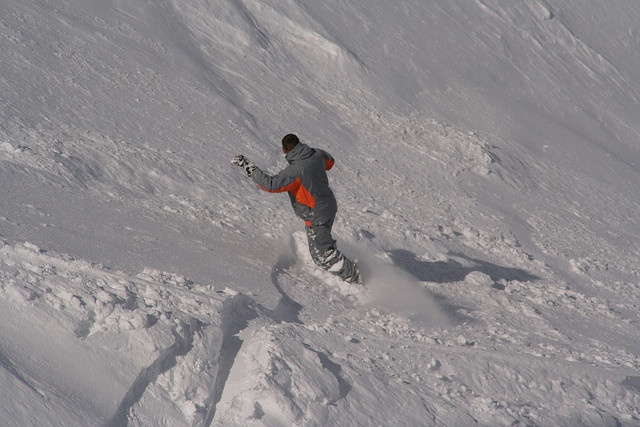Describe the objects in this image and their specific colors. I can see people in gray, black, darkgray, and brown tones and snowboard in gray, darkgray, and lightgray tones in this image. 